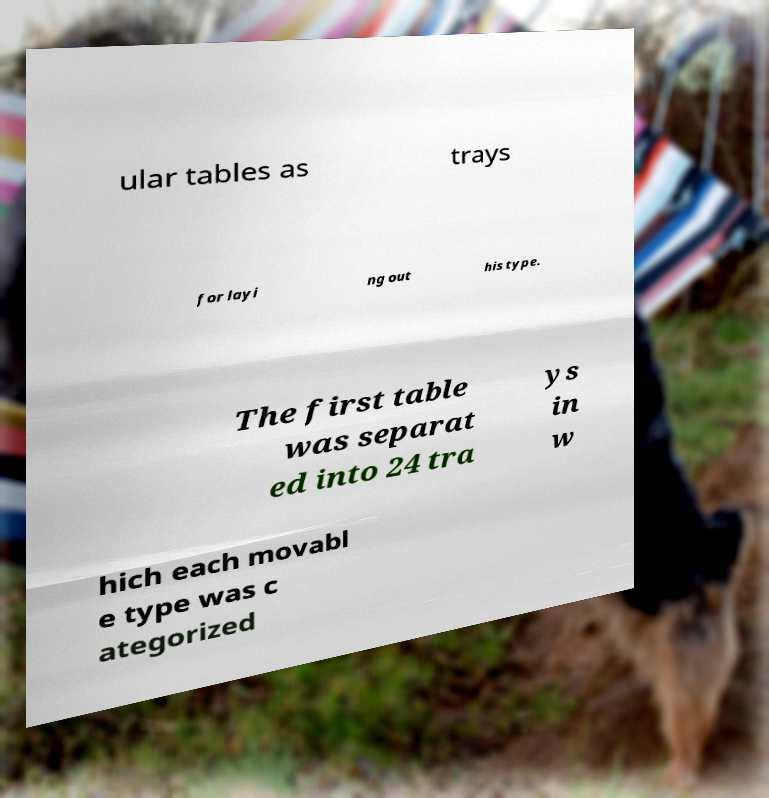Please identify and transcribe the text found in this image. ular tables as trays for layi ng out his type. The first table was separat ed into 24 tra ys in w hich each movabl e type was c ategorized 